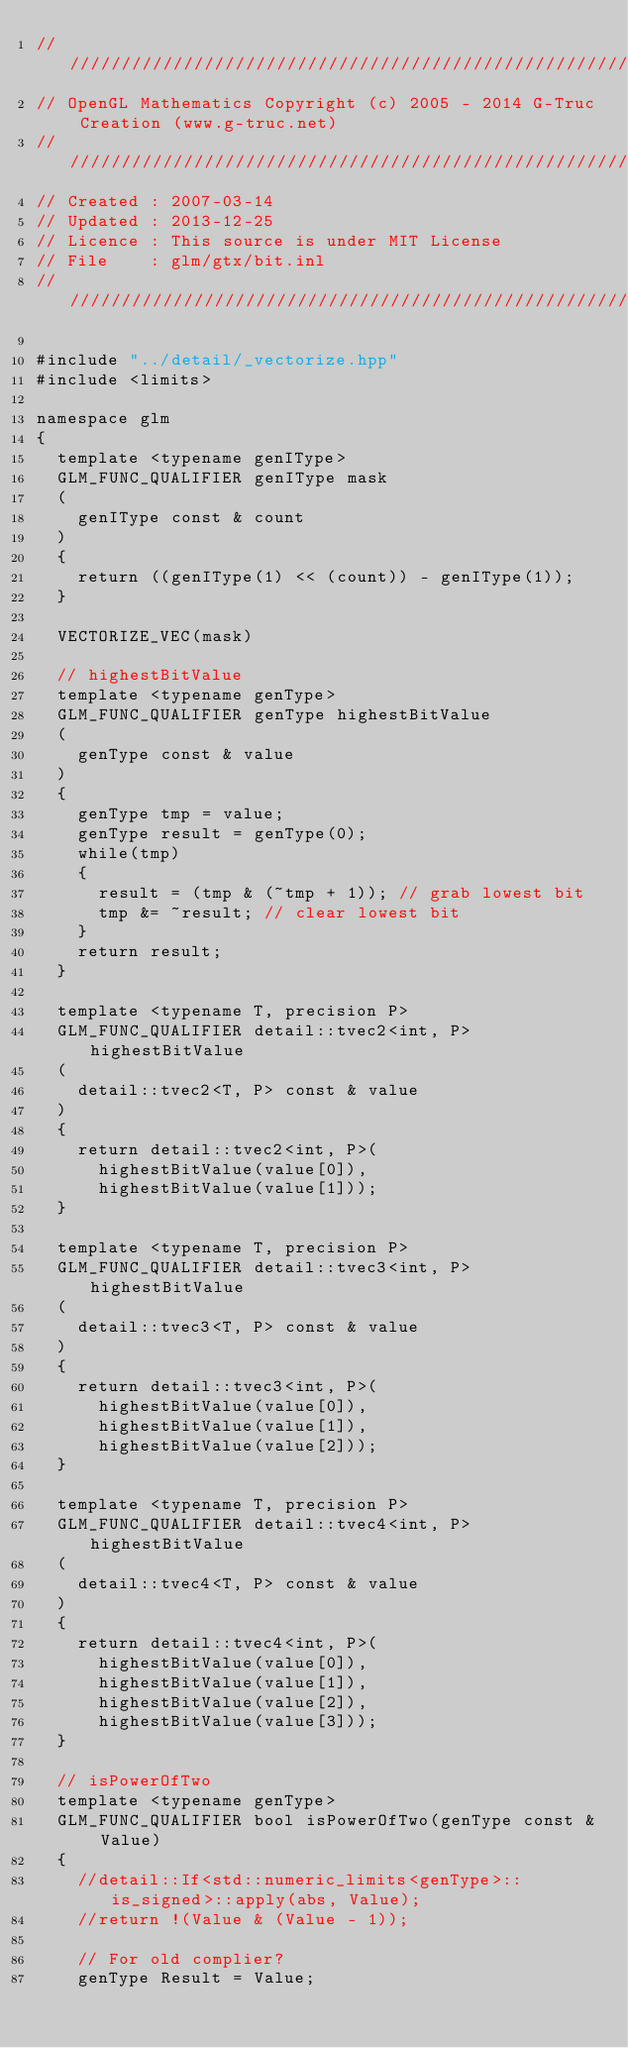Convert code to text. <code><loc_0><loc_0><loc_500><loc_500><_C++_>///////////////////////////////////////////////////////////////////////////////////////////////////
// OpenGL Mathematics Copyright (c) 2005 - 2014 G-Truc Creation (www.g-truc.net)
///////////////////////////////////////////////////////////////////////////////////////////////////
// Created : 2007-03-14
// Updated : 2013-12-25
// Licence : This source is under MIT License
// File    : glm/gtx/bit.inl
///////////////////////////////////////////////////////////////////////////////////////////////////

#include "../detail/_vectorize.hpp"
#include <limits>

namespace glm
{
	template <typename genIType>
	GLM_FUNC_QUALIFIER genIType mask
	(
		genIType const & count
	)
	{
		return ((genIType(1) << (count)) - genIType(1));
	}

	VECTORIZE_VEC(mask)

	// highestBitValue
	template <typename genType>
	GLM_FUNC_QUALIFIER genType highestBitValue
	(
		genType const & value
	)
	{
		genType tmp = value;
		genType result = genType(0);
		while(tmp)
		{
			result = (tmp & (~tmp + 1)); // grab lowest bit
			tmp &= ~result; // clear lowest bit
		}
		return result;
	}

	template <typename T, precision P>
	GLM_FUNC_QUALIFIER detail::tvec2<int, P> highestBitValue
	(
		detail::tvec2<T, P> const & value
	)
	{
		return detail::tvec2<int, P>(
			highestBitValue(value[0]),
			highestBitValue(value[1]));
	}

	template <typename T, precision P>
	GLM_FUNC_QUALIFIER detail::tvec3<int, P> highestBitValue
	(
		detail::tvec3<T, P> const & value
	)
	{
		return detail::tvec3<int, P>(
			highestBitValue(value[0]),
			highestBitValue(value[1]),
			highestBitValue(value[2]));
	}

	template <typename T, precision P>
	GLM_FUNC_QUALIFIER detail::tvec4<int, P> highestBitValue
	(
		detail::tvec4<T, P> const & value
	)
	{
		return detail::tvec4<int, P>(
			highestBitValue(value[0]),
			highestBitValue(value[1]),
			highestBitValue(value[2]),
			highestBitValue(value[3]));
	}

	// isPowerOfTwo
	template <typename genType>
	GLM_FUNC_QUALIFIER bool isPowerOfTwo(genType const & Value)
	{
		//detail::If<std::numeric_limits<genType>::is_signed>::apply(abs, Value);
		//return !(Value & (Value - 1));

		// For old complier?
		genType Result = Value;</code> 